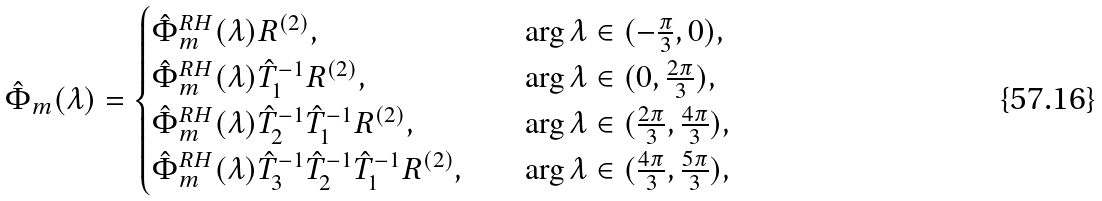<formula> <loc_0><loc_0><loc_500><loc_500>\hat { \Phi } _ { m } ( \lambda ) = \begin{cases} \hat { \Phi } _ { m } ^ { R H } ( \lambda ) R ^ { ( 2 ) } , \quad & \arg \lambda \in ( - \frac { \pi } { 3 } , 0 ) , \\ \hat { \Phi } _ { m } ^ { R H } ( \lambda ) \hat { T } _ { 1 } ^ { - 1 } R ^ { ( 2 ) } , \quad & \arg \lambda \in ( 0 , \frac { 2 \pi } { 3 } ) , \\ \hat { \Phi } _ { m } ^ { R H } ( \lambda ) \hat { T } _ { 2 } ^ { - 1 } \hat { T } _ { 1 } ^ { - 1 } R ^ { ( 2 ) } , \quad & \arg \lambda \in ( \frac { 2 \pi } { 3 } , \frac { 4 \pi } { 3 } ) , \\ \hat { \Phi } _ { m } ^ { R H } ( \lambda ) \hat { T } _ { 3 } ^ { - 1 } \hat { T } _ { 2 } ^ { - 1 } \hat { T } _ { 1 } ^ { - 1 } R ^ { ( 2 ) } , \quad & \arg \lambda \in ( \frac { 4 \pi } { 3 } , \frac { 5 \pi } { 3 } ) , \end{cases}</formula> 